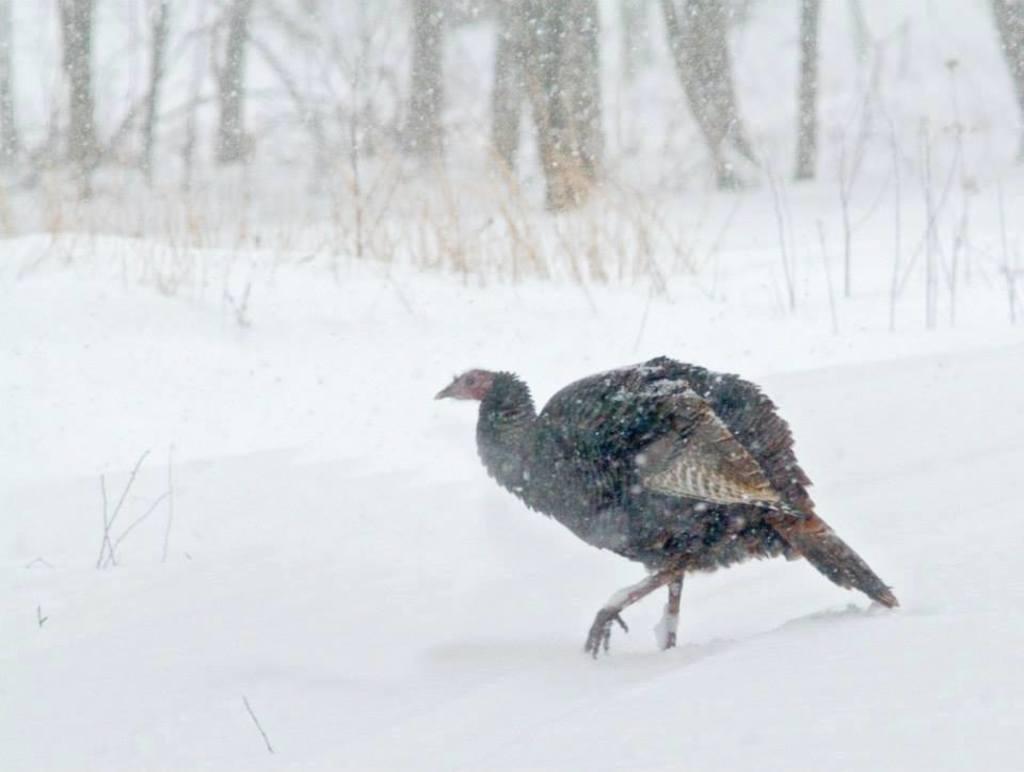How would you summarize this image in a sentence or two? In this image I can see ground full of snow and in the front I can see a bird on it. I can see colour of this bird is black. In the background I can see grass and I can see this image is little bit blurry in the background. 